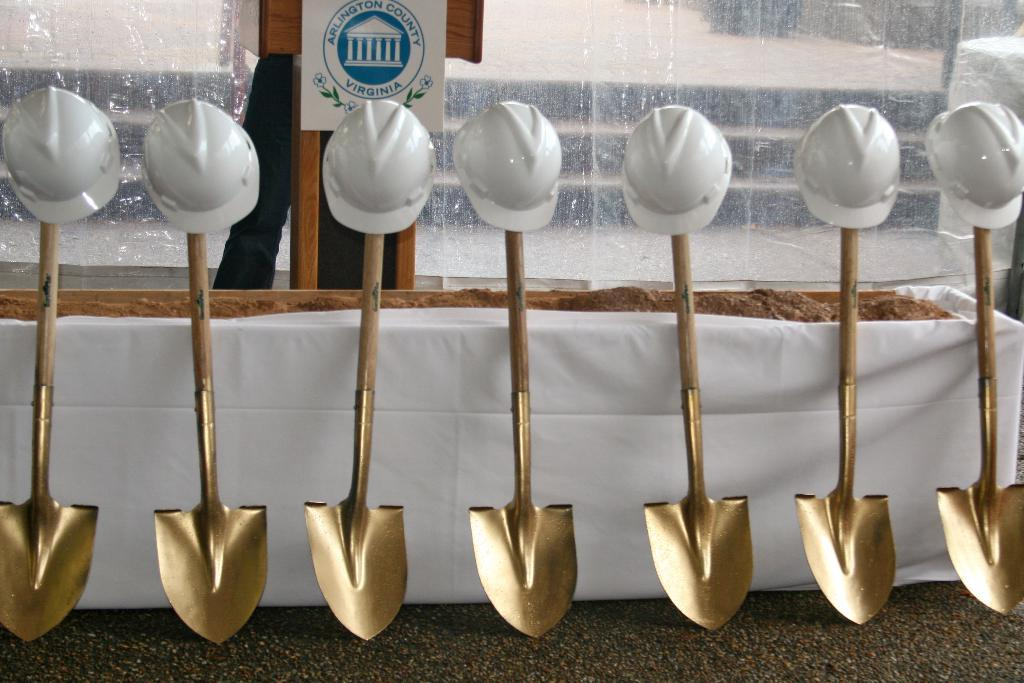What type of utensils are present in the image? There are glass trowels in the image. What can be seen in the background of the image? There is a glass and a name board in the background of the image. How many bikes are parked next to the name board in the image? There are no bikes present in the image; it only features glass trowels, a glass, and a name board. 